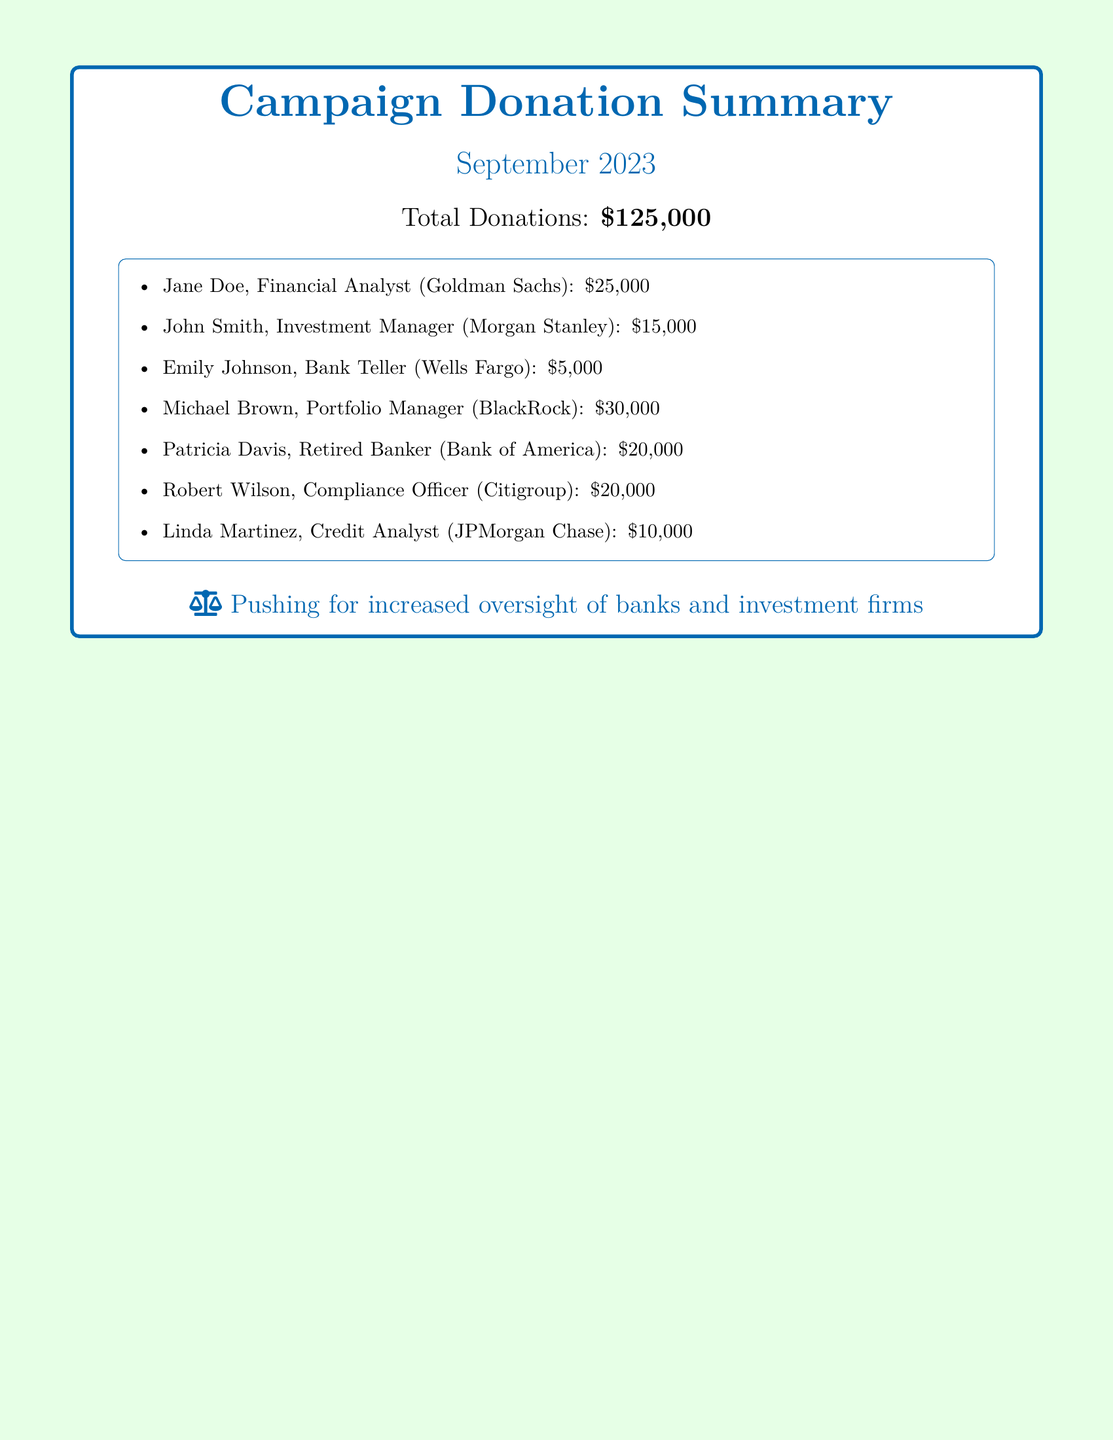What was the total amount of donations? The total donations are clearly stated in the document as being $125,000.
Answer: $125,000 Who contributed the highest amount? The individual with the highest contribution is Michael Brown, who donated $30,000.
Answer: Michael Brown Which organization does Jane Doe work for? Jane Doe is identified as a Financial Analyst at Goldman Sachs.
Answer: Goldman Sachs How many donations were made from compliance-related positions? There are two contributions listed from compliance-related positions (Robert Wilson, Compliance Officer; total of $20,000).
Answer: 2 What was the contribution amount from Patricia Davis? The document states that Patricia Davis contributed $20,000.
Answer: $20,000 What position does Linda Martinez hold? Linda Martinez is listed as a Credit Analyst.
Answer: Credit Analyst Which month is covered in this donation summary? The document is specifically summarizing donations for September 2023.
Answer: September 2023 What is the underlying theme of the document? The document emphasizes the push for increased oversight of banks and investment firms.
Answer: Increased oversight of banks and investment firms How many donors are mentioned in the document? The document lists a total of seven donors contributing to the campaign.
Answer: 7 